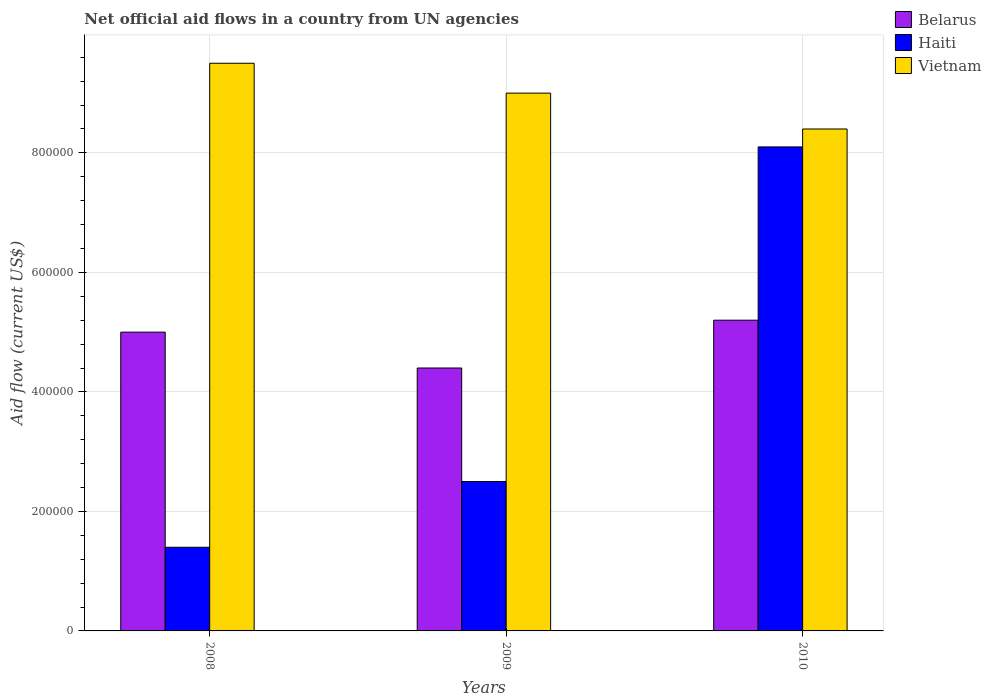How many bars are there on the 2nd tick from the left?
Your answer should be very brief. 3. What is the net official aid flow in Haiti in 2008?
Offer a terse response. 1.40e+05. Across all years, what is the maximum net official aid flow in Belarus?
Your answer should be compact. 5.20e+05. Across all years, what is the minimum net official aid flow in Vietnam?
Offer a very short reply. 8.40e+05. In which year was the net official aid flow in Vietnam minimum?
Provide a succinct answer. 2010. What is the total net official aid flow in Belarus in the graph?
Your response must be concise. 1.46e+06. What is the difference between the net official aid flow in Belarus in 2009 and that in 2010?
Make the answer very short. -8.00e+04. What is the difference between the net official aid flow in Haiti in 2008 and the net official aid flow in Vietnam in 2010?
Provide a short and direct response. -7.00e+05. In the year 2009, what is the difference between the net official aid flow in Belarus and net official aid flow in Vietnam?
Provide a succinct answer. -4.60e+05. What is the ratio of the net official aid flow in Haiti in 2009 to that in 2010?
Make the answer very short. 0.31. Is the net official aid flow in Belarus in 2008 less than that in 2009?
Offer a very short reply. No. Is the difference between the net official aid flow in Belarus in 2009 and 2010 greater than the difference between the net official aid flow in Vietnam in 2009 and 2010?
Offer a very short reply. No. What is the difference between the highest and the second highest net official aid flow in Haiti?
Your answer should be compact. 5.60e+05. What is the difference between the highest and the lowest net official aid flow in Haiti?
Provide a short and direct response. 6.70e+05. Is the sum of the net official aid flow in Vietnam in 2008 and 2009 greater than the maximum net official aid flow in Haiti across all years?
Your response must be concise. Yes. What does the 3rd bar from the left in 2009 represents?
Your answer should be very brief. Vietnam. What does the 1st bar from the right in 2009 represents?
Give a very brief answer. Vietnam. Is it the case that in every year, the sum of the net official aid flow in Haiti and net official aid flow in Belarus is greater than the net official aid flow in Vietnam?
Your response must be concise. No. Are all the bars in the graph horizontal?
Offer a terse response. No. What is the difference between two consecutive major ticks on the Y-axis?
Make the answer very short. 2.00e+05. Does the graph contain any zero values?
Provide a succinct answer. No. Does the graph contain grids?
Give a very brief answer. Yes. Where does the legend appear in the graph?
Give a very brief answer. Top right. How many legend labels are there?
Give a very brief answer. 3. How are the legend labels stacked?
Provide a short and direct response. Vertical. What is the title of the graph?
Give a very brief answer. Net official aid flows in a country from UN agencies. What is the Aid flow (current US$) in Haiti in 2008?
Provide a short and direct response. 1.40e+05. What is the Aid flow (current US$) in Vietnam in 2008?
Give a very brief answer. 9.50e+05. What is the Aid flow (current US$) in Belarus in 2010?
Offer a terse response. 5.20e+05. What is the Aid flow (current US$) of Haiti in 2010?
Ensure brevity in your answer.  8.10e+05. What is the Aid flow (current US$) of Vietnam in 2010?
Your response must be concise. 8.40e+05. Across all years, what is the maximum Aid flow (current US$) in Belarus?
Offer a very short reply. 5.20e+05. Across all years, what is the maximum Aid flow (current US$) in Haiti?
Your response must be concise. 8.10e+05. Across all years, what is the maximum Aid flow (current US$) in Vietnam?
Give a very brief answer. 9.50e+05. Across all years, what is the minimum Aid flow (current US$) in Belarus?
Offer a very short reply. 4.40e+05. Across all years, what is the minimum Aid flow (current US$) of Haiti?
Make the answer very short. 1.40e+05. Across all years, what is the minimum Aid flow (current US$) in Vietnam?
Ensure brevity in your answer.  8.40e+05. What is the total Aid flow (current US$) of Belarus in the graph?
Ensure brevity in your answer.  1.46e+06. What is the total Aid flow (current US$) of Haiti in the graph?
Ensure brevity in your answer.  1.20e+06. What is the total Aid flow (current US$) in Vietnam in the graph?
Make the answer very short. 2.69e+06. What is the difference between the Aid flow (current US$) of Belarus in 2008 and that in 2009?
Offer a very short reply. 6.00e+04. What is the difference between the Aid flow (current US$) of Haiti in 2008 and that in 2009?
Ensure brevity in your answer.  -1.10e+05. What is the difference between the Aid flow (current US$) in Vietnam in 2008 and that in 2009?
Your response must be concise. 5.00e+04. What is the difference between the Aid flow (current US$) of Haiti in 2008 and that in 2010?
Your response must be concise. -6.70e+05. What is the difference between the Aid flow (current US$) of Vietnam in 2008 and that in 2010?
Provide a short and direct response. 1.10e+05. What is the difference between the Aid flow (current US$) of Haiti in 2009 and that in 2010?
Provide a short and direct response. -5.60e+05. What is the difference between the Aid flow (current US$) of Belarus in 2008 and the Aid flow (current US$) of Vietnam in 2009?
Your response must be concise. -4.00e+05. What is the difference between the Aid flow (current US$) in Haiti in 2008 and the Aid flow (current US$) in Vietnam in 2009?
Give a very brief answer. -7.60e+05. What is the difference between the Aid flow (current US$) of Belarus in 2008 and the Aid flow (current US$) of Haiti in 2010?
Give a very brief answer. -3.10e+05. What is the difference between the Aid flow (current US$) of Belarus in 2008 and the Aid flow (current US$) of Vietnam in 2010?
Give a very brief answer. -3.40e+05. What is the difference between the Aid flow (current US$) in Haiti in 2008 and the Aid flow (current US$) in Vietnam in 2010?
Your response must be concise. -7.00e+05. What is the difference between the Aid flow (current US$) in Belarus in 2009 and the Aid flow (current US$) in Haiti in 2010?
Give a very brief answer. -3.70e+05. What is the difference between the Aid flow (current US$) of Belarus in 2009 and the Aid flow (current US$) of Vietnam in 2010?
Offer a very short reply. -4.00e+05. What is the difference between the Aid flow (current US$) of Haiti in 2009 and the Aid flow (current US$) of Vietnam in 2010?
Offer a terse response. -5.90e+05. What is the average Aid flow (current US$) in Belarus per year?
Offer a very short reply. 4.87e+05. What is the average Aid flow (current US$) in Haiti per year?
Offer a very short reply. 4.00e+05. What is the average Aid flow (current US$) in Vietnam per year?
Give a very brief answer. 8.97e+05. In the year 2008, what is the difference between the Aid flow (current US$) of Belarus and Aid flow (current US$) of Vietnam?
Provide a succinct answer. -4.50e+05. In the year 2008, what is the difference between the Aid flow (current US$) in Haiti and Aid flow (current US$) in Vietnam?
Your answer should be very brief. -8.10e+05. In the year 2009, what is the difference between the Aid flow (current US$) of Belarus and Aid flow (current US$) of Vietnam?
Provide a succinct answer. -4.60e+05. In the year 2009, what is the difference between the Aid flow (current US$) in Haiti and Aid flow (current US$) in Vietnam?
Ensure brevity in your answer.  -6.50e+05. In the year 2010, what is the difference between the Aid flow (current US$) of Belarus and Aid flow (current US$) of Haiti?
Your answer should be very brief. -2.90e+05. In the year 2010, what is the difference between the Aid flow (current US$) of Belarus and Aid flow (current US$) of Vietnam?
Keep it short and to the point. -3.20e+05. What is the ratio of the Aid flow (current US$) in Belarus in 2008 to that in 2009?
Ensure brevity in your answer.  1.14. What is the ratio of the Aid flow (current US$) of Haiti in 2008 to that in 2009?
Your response must be concise. 0.56. What is the ratio of the Aid flow (current US$) of Vietnam in 2008 to that in 2009?
Your answer should be compact. 1.06. What is the ratio of the Aid flow (current US$) in Belarus in 2008 to that in 2010?
Your answer should be compact. 0.96. What is the ratio of the Aid flow (current US$) of Haiti in 2008 to that in 2010?
Ensure brevity in your answer.  0.17. What is the ratio of the Aid flow (current US$) in Vietnam in 2008 to that in 2010?
Your response must be concise. 1.13. What is the ratio of the Aid flow (current US$) of Belarus in 2009 to that in 2010?
Offer a very short reply. 0.85. What is the ratio of the Aid flow (current US$) of Haiti in 2009 to that in 2010?
Give a very brief answer. 0.31. What is the ratio of the Aid flow (current US$) in Vietnam in 2009 to that in 2010?
Make the answer very short. 1.07. What is the difference between the highest and the second highest Aid flow (current US$) of Belarus?
Offer a terse response. 2.00e+04. What is the difference between the highest and the second highest Aid flow (current US$) in Haiti?
Keep it short and to the point. 5.60e+05. What is the difference between the highest and the second highest Aid flow (current US$) in Vietnam?
Provide a succinct answer. 5.00e+04. What is the difference between the highest and the lowest Aid flow (current US$) of Belarus?
Your response must be concise. 8.00e+04. What is the difference between the highest and the lowest Aid flow (current US$) in Haiti?
Offer a very short reply. 6.70e+05. 